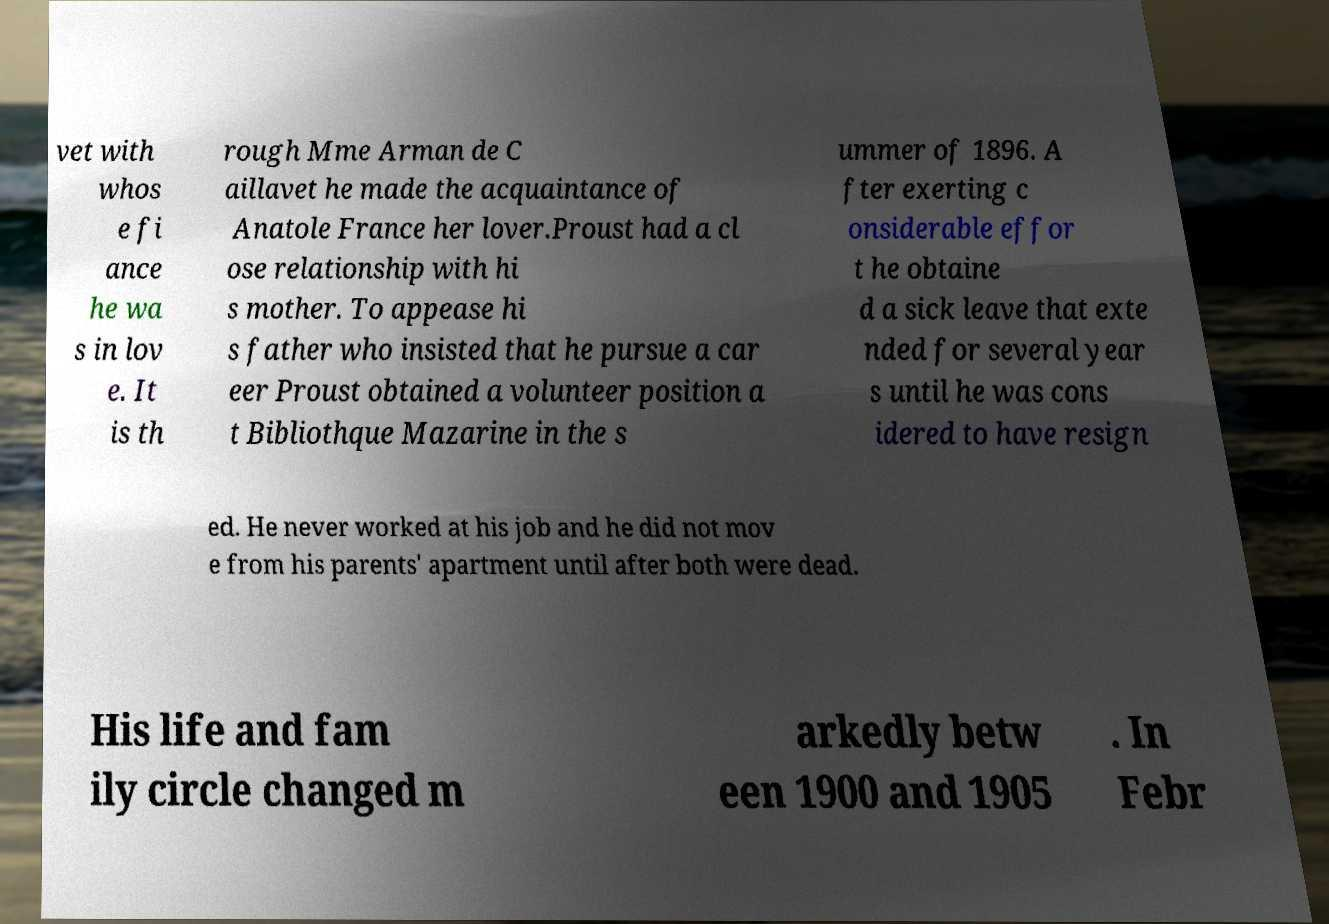There's text embedded in this image that I need extracted. Can you transcribe it verbatim? vet with whos e fi ance he wa s in lov e. It is th rough Mme Arman de C aillavet he made the acquaintance of Anatole France her lover.Proust had a cl ose relationship with hi s mother. To appease hi s father who insisted that he pursue a car eer Proust obtained a volunteer position a t Bibliothque Mazarine in the s ummer of 1896. A fter exerting c onsiderable effor t he obtaine d a sick leave that exte nded for several year s until he was cons idered to have resign ed. He never worked at his job and he did not mov e from his parents' apartment until after both were dead. His life and fam ily circle changed m arkedly betw een 1900 and 1905 . In Febr 